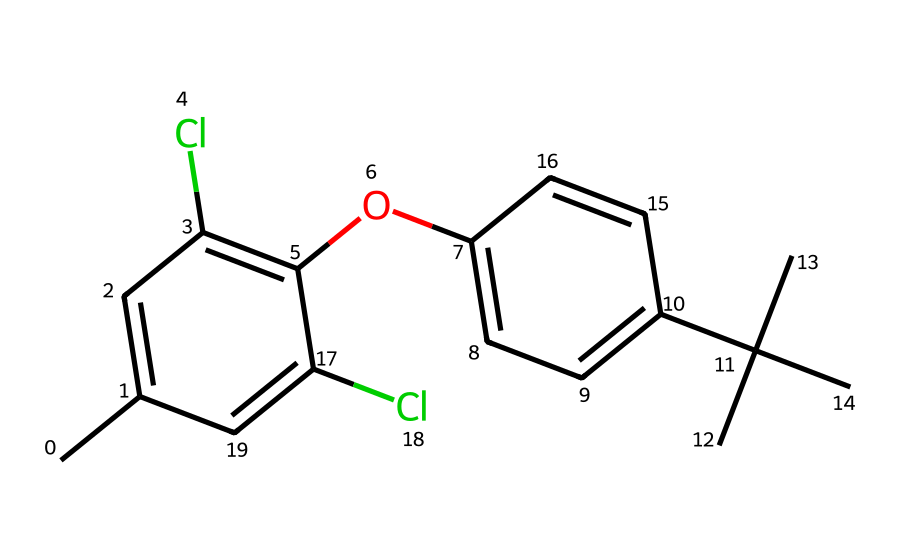What is the molecular formula of this chemical? To find the molecular formula, count the number of each type of atom in the given SMILES representation. The atoms present include 12 carbon (C), 14 hydrogen (H), 2 chlorine (Cl), and 1 oxygen (O), leading to the formula C12H14Cl2O.
Answer: C12H14Cl2O How many chlorine atoms are present? By examining the SMILES structure, there are two instances of chlorine (Cl) indicated, confirming that there are 2 chlorine atoms.
Answer: 2 What type of chemical functional group does this compound contain? In the chemical structure, the presence of -OH (hydroxyl group) indicates that this compound is a phenol, as all phenols have this functional group.
Answer: hydroxyl Which part of the molecule contributes to its herbicidal activity? The structure contains a phenolic ring which is common in many herbicides due to its ability to interact with biological systems. The presence of chlorine substituents may also enhance herbicidal properties through increased lipophilicity.
Answer: phenolic ring Is this compound likely to be hydrophilic or hydrophobic? The presence of a bulky isopropyl group and chlorines suggests increased hydrophobicity, while the hydroxyl group provides hydrophilic character. Overall, due to the dominant effects of the bulky groups, the compound is likely more hydrophobic.
Answer: hydrophobic How many aromatic rings does the structure contain? The structure consists of two aromatic rings; one is part of the phenolic structure and the other is a t-butyl-substituted aromatic moiety.
Answer: 2 